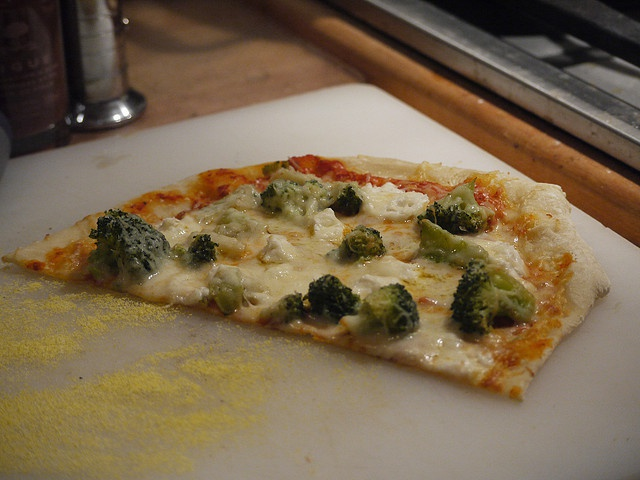Describe the objects in this image and their specific colors. I can see pizza in black, tan, and olive tones, broccoli in black and olive tones, broccoli in black, darkgreen, gray, and maroon tones, broccoli in black, darkgreen, and tan tones, and broccoli in black and olive tones in this image. 